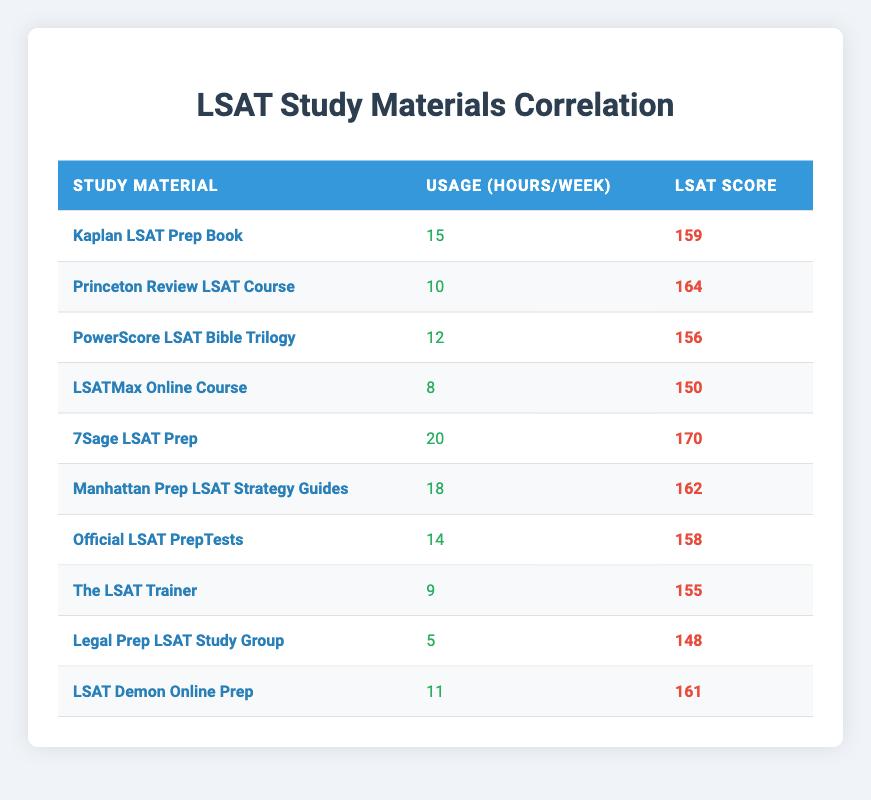What is the LSAT score for the 7Sage LSAT Prep? The table shows the specific LSAT scores associated with each study material. For 7Sage LSAT Prep, the LSAT score is listed in the third column next to its name in the first column.
Answer: 170 How many hours per week are allocated to studying with the LSATMax Online Course? The table provides the usage hours per week for each study material in the second column. For LSATMax Online Course, the usage hours per week is clearly listed there.
Answer: 8 What is the average LSAT score of all study materials listed? To find the average LSAT score, we first sum all the individual scores: (159 + 164 + 156 + 150 + 170 + 162 + 158 + 155 + 148 + 161) = 1,617. Then, we divide this sum by the total number of materials, which is 10. So, the average score is 1,617 / 10 = 161.7.
Answer: 161.7 Did any study material result in an LSAT score of 148? We check the LSAT scores in the table to see if any study material has the score of 148. Upon reviewing the scores, we find that the Legal Prep LSAT Study Group has the LSAT score of 148.
Answer: Yes Which study material requires the most hours of study per week, and what is the corresponding LSAT score? By looking through the usage hours per week in the second column, we identify that 7Sage LSAT Prep requires 20 hours per week, which is the highest. The corresponding LSAT score for this material is 170, as seen in the third column.
Answer: 7Sage LSAT Prep, 170 What is the difference in LSAT scores between the highest and lowest scoring study materials? The highest LSAT score is from 7Sage LSAT Prep (170) and the lowest is from Legal Prep LSAT Study Group (148). The difference is calculated as: 170 - 148 = 22.
Answer: 22 How many study materials have usage hours greater than 10 hours per week? We review the usage hours per week for each study material and count those that are above 10 hours. The materials that meet this criterion are: Kaplan LSAT Prep Book (15), Princeton Review LSAT Course (10), PowerScore LSAT Bible Trilogy (12), 7Sage LSAT Prep (20), Manhattan Prep LSAT Strategy Guides (18), Official LSAT PrepTests (14), and LSAT Demon Online Prep (11). This makes a total of 6 study materials.
Answer: 6 Is there a study material with a usage hour of 5 per week that has an LSAT score above 150? The only material listed with 5 usage hours per week is Legal Prep LSAT Study Group, and its LSAT score is 148, which is not above 150. Therefore, there is no study material that meets these criteria.
Answer: No What is the LSAT score of the study material with 11 usage hours per week? We refer to the second column and find the row with 11 usage hours, which corresponds to LSAT Demon Online Prep. The LSAT score listed for this material is found in the third column.
Answer: 161 